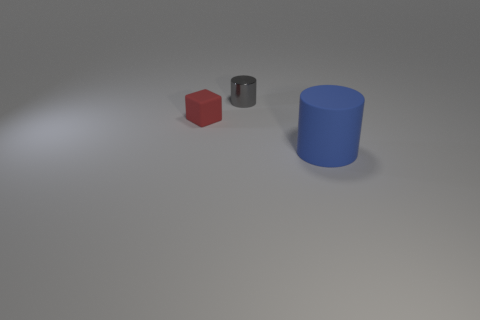Add 3 gray shiny objects. How many objects exist? 6 Subtract all cubes. How many objects are left? 2 Add 2 red metal balls. How many red metal balls exist? 2 Subtract 0 green blocks. How many objects are left? 3 Subtract all rubber cylinders. Subtract all small rubber cubes. How many objects are left? 1 Add 3 tiny gray objects. How many tiny gray objects are left? 4 